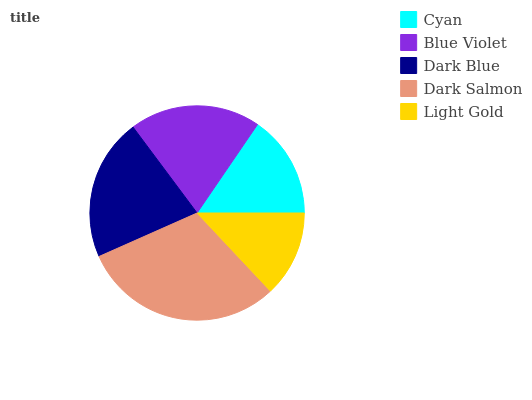Is Light Gold the minimum?
Answer yes or no. Yes. Is Dark Salmon the maximum?
Answer yes or no. Yes. Is Blue Violet the minimum?
Answer yes or no. No. Is Blue Violet the maximum?
Answer yes or no. No. Is Blue Violet greater than Cyan?
Answer yes or no. Yes. Is Cyan less than Blue Violet?
Answer yes or no. Yes. Is Cyan greater than Blue Violet?
Answer yes or no. No. Is Blue Violet less than Cyan?
Answer yes or no. No. Is Blue Violet the high median?
Answer yes or no. Yes. Is Blue Violet the low median?
Answer yes or no. Yes. Is Light Gold the high median?
Answer yes or no. No. Is Dark Salmon the low median?
Answer yes or no. No. 